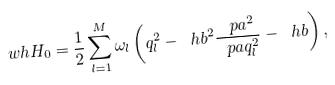<formula> <loc_0><loc_0><loc_500><loc_500>\ w h { H } _ { 0 } = \frac { 1 } { 2 } \sum ^ { M } _ { l = 1 } \omega _ { l } \left ( q ^ { 2 } _ { l } - \ h b ^ { 2 } \frac { \ p a ^ { 2 } } { \ p a q ^ { 2 } _ { l } } - \ h b \right ) ,</formula> 